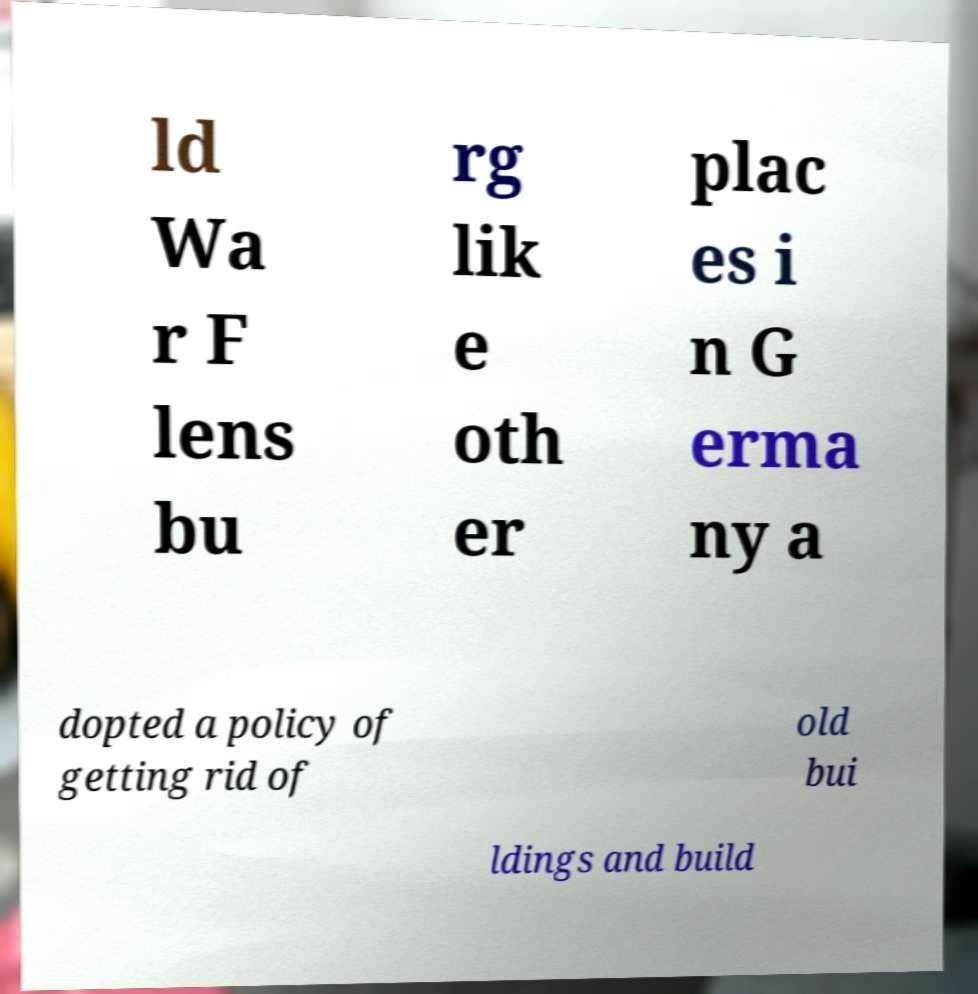Please identify and transcribe the text found in this image. ld Wa r F lens bu rg lik e oth er plac es i n G erma ny a dopted a policy of getting rid of old bui ldings and build 